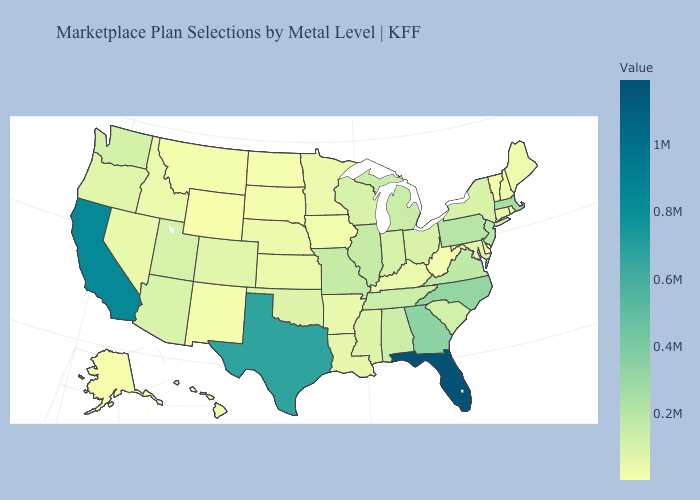Among the states that border South Dakota , does North Dakota have the highest value?
Quick response, please. No. Which states have the lowest value in the MidWest?
Concise answer only. North Dakota. Does Texas have a higher value than California?
Be succinct. No. 